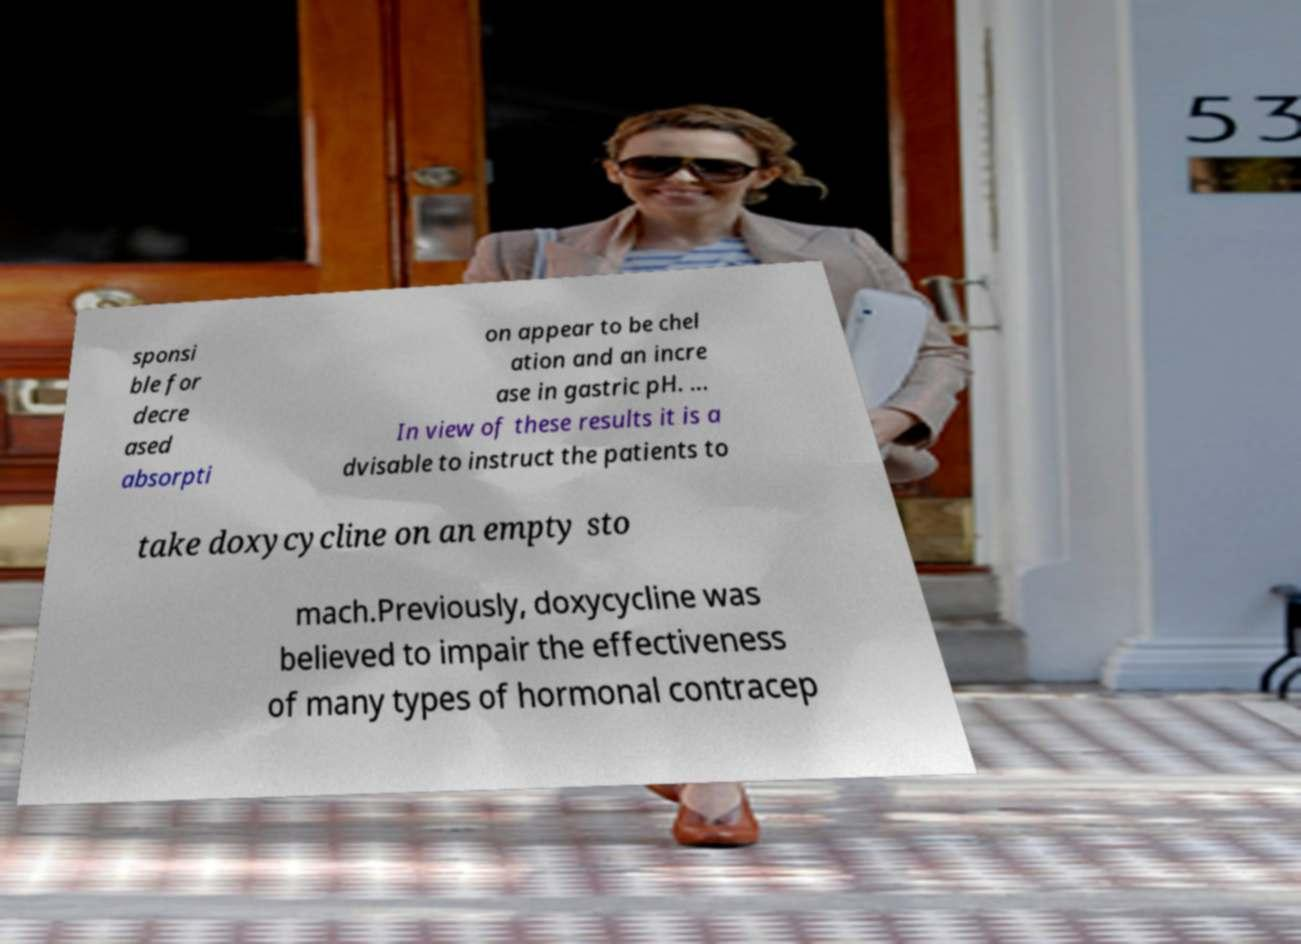Could you assist in decoding the text presented in this image and type it out clearly? sponsi ble for decre ased absorpti on appear to be chel ation and an incre ase in gastric pH. ... In view of these results it is a dvisable to instruct the patients to take doxycycline on an empty sto mach.Previously, doxycycline was believed to impair the effectiveness of many types of hormonal contracep 